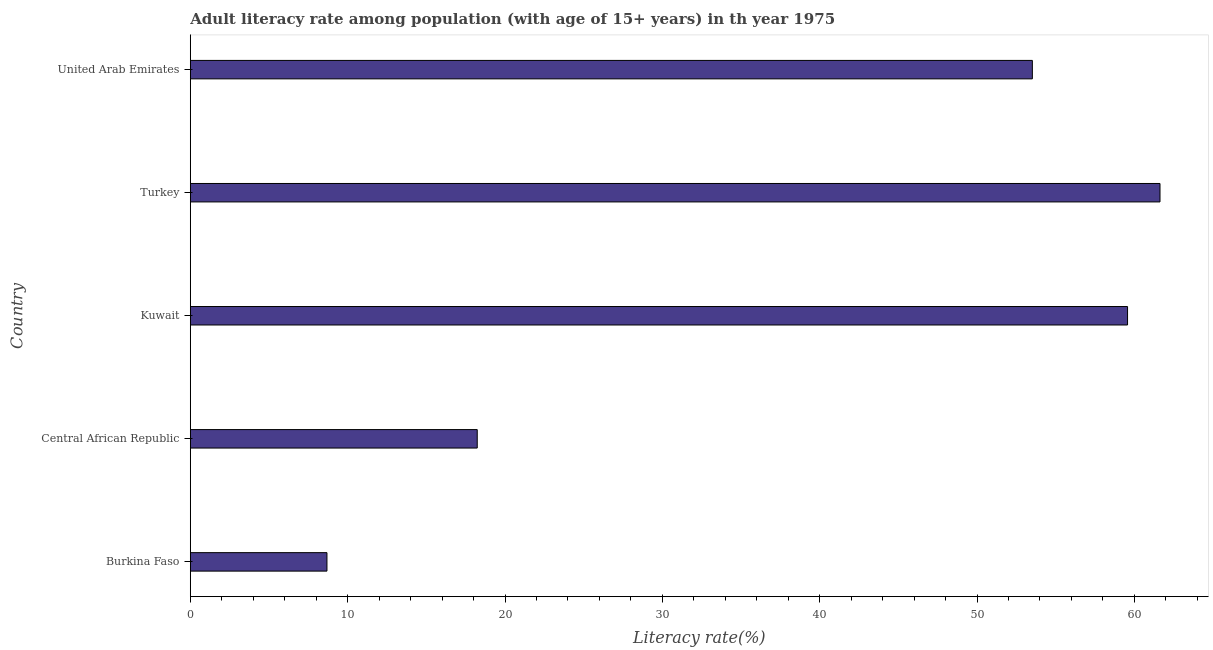Does the graph contain any zero values?
Provide a short and direct response. No. What is the title of the graph?
Give a very brief answer. Adult literacy rate among population (with age of 15+ years) in th year 1975. What is the label or title of the X-axis?
Give a very brief answer. Literacy rate(%). What is the label or title of the Y-axis?
Give a very brief answer. Country. What is the adult literacy rate in Kuwait?
Provide a succinct answer. 59.56. Across all countries, what is the maximum adult literacy rate?
Your response must be concise. 61.63. Across all countries, what is the minimum adult literacy rate?
Your answer should be compact. 8.69. In which country was the adult literacy rate minimum?
Make the answer very short. Burkina Faso. What is the sum of the adult literacy rate?
Make the answer very short. 201.63. What is the difference between the adult literacy rate in Turkey and United Arab Emirates?
Ensure brevity in your answer.  8.11. What is the average adult literacy rate per country?
Ensure brevity in your answer.  40.33. What is the median adult literacy rate?
Give a very brief answer. 53.51. In how many countries, is the adult literacy rate greater than 52 %?
Offer a very short reply. 3. What is the ratio of the adult literacy rate in Burkina Faso to that in Central African Republic?
Make the answer very short. 0.48. What is the difference between the highest and the second highest adult literacy rate?
Offer a terse response. 2.06. What is the difference between the highest and the lowest adult literacy rate?
Ensure brevity in your answer.  52.94. Are all the bars in the graph horizontal?
Keep it short and to the point. Yes. How many countries are there in the graph?
Make the answer very short. 5. What is the difference between two consecutive major ticks on the X-axis?
Keep it short and to the point. 10. Are the values on the major ticks of X-axis written in scientific E-notation?
Provide a succinct answer. No. What is the Literacy rate(%) in Burkina Faso?
Keep it short and to the point. 8.69. What is the Literacy rate(%) of Central African Republic?
Provide a short and direct response. 18.24. What is the Literacy rate(%) in Kuwait?
Your answer should be very brief. 59.56. What is the Literacy rate(%) of Turkey?
Ensure brevity in your answer.  61.63. What is the Literacy rate(%) in United Arab Emirates?
Offer a terse response. 53.51. What is the difference between the Literacy rate(%) in Burkina Faso and Central African Republic?
Your response must be concise. -9.55. What is the difference between the Literacy rate(%) in Burkina Faso and Kuwait?
Your response must be concise. -50.88. What is the difference between the Literacy rate(%) in Burkina Faso and Turkey?
Offer a very short reply. -52.94. What is the difference between the Literacy rate(%) in Burkina Faso and United Arab Emirates?
Ensure brevity in your answer.  -44.83. What is the difference between the Literacy rate(%) in Central African Republic and Kuwait?
Offer a very short reply. -41.33. What is the difference between the Literacy rate(%) in Central African Republic and Turkey?
Provide a short and direct response. -43.39. What is the difference between the Literacy rate(%) in Central African Republic and United Arab Emirates?
Provide a short and direct response. -35.28. What is the difference between the Literacy rate(%) in Kuwait and Turkey?
Your answer should be compact. -2.06. What is the difference between the Literacy rate(%) in Kuwait and United Arab Emirates?
Provide a succinct answer. 6.05. What is the difference between the Literacy rate(%) in Turkey and United Arab Emirates?
Provide a short and direct response. 8.11. What is the ratio of the Literacy rate(%) in Burkina Faso to that in Central African Republic?
Make the answer very short. 0.48. What is the ratio of the Literacy rate(%) in Burkina Faso to that in Kuwait?
Provide a succinct answer. 0.15. What is the ratio of the Literacy rate(%) in Burkina Faso to that in Turkey?
Provide a short and direct response. 0.14. What is the ratio of the Literacy rate(%) in Burkina Faso to that in United Arab Emirates?
Make the answer very short. 0.16. What is the ratio of the Literacy rate(%) in Central African Republic to that in Kuwait?
Make the answer very short. 0.31. What is the ratio of the Literacy rate(%) in Central African Republic to that in Turkey?
Offer a very short reply. 0.3. What is the ratio of the Literacy rate(%) in Central African Republic to that in United Arab Emirates?
Make the answer very short. 0.34. What is the ratio of the Literacy rate(%) in Kuwait to that in Turkey?
Your answer should be compact. 0.97. What is the ratio of the Literacy rate(%) in Kuwait to that in United Arab Emirates?
Keep it short and to the point. 1.11. What is the ratio of the Literacy rate(%) in Turkey to that in United Arab Emirates?
Keep it short and to the point. 1.15. 